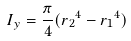Convert formula to latex. <formula><loc_0><loc_0><loc_500><loc_500>I _ { y } = \frac { \pi } { 4 } ( { r _ { 2 } } ^ { 4 } - { r _ { 1 } } ^ { 4 } )</formula> 